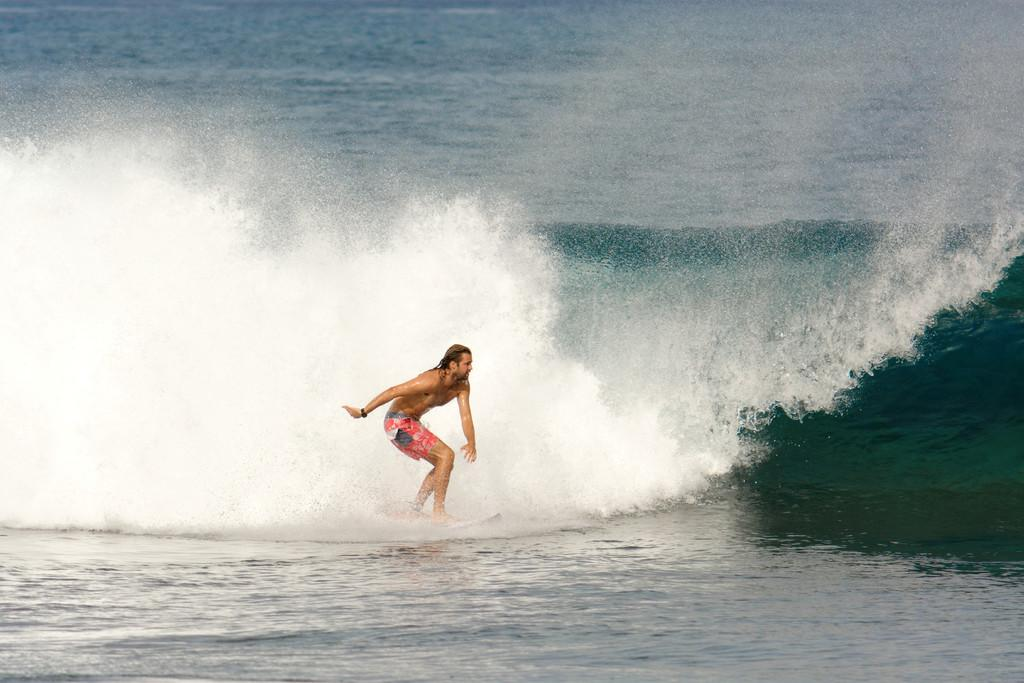What is the person in the image doing? The person is in the water. What is the person wearing? The person is wearing an orange-colored short. What other object is visible in the image? There is a surfboard in the image. What type of gold jewelry is the person wearing in the image? There is no gold jewelry visible in the image. What type of water activity is the person participating in with the spade? There is no spade present in the image, and the person is not participating in any water activity with a spade. 